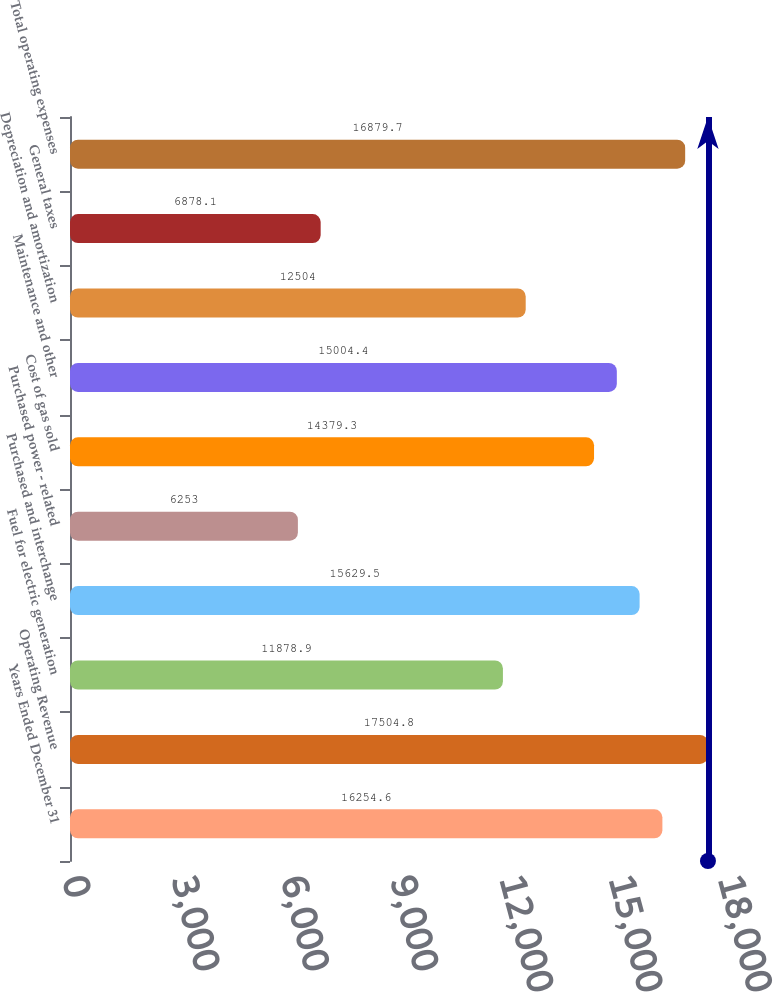Convert chart. <chart><loc_0><loc_0><loc_500><loc_500><bar_chart><fcel>Years Ended December 31<fcel>Operating Revenue<fcel>Fuel for electric generation<fcel>Purchased and interchange<fcel>Purchased power - related<fcel>Cost of gas sold<fcel>Maintenance and other<fcel>Depreciation and amortization<fcel>General taxes<fcel>Total operating expenses<nl><fcel>16254.6<fcel>17504.8<fcel>11878.9<fcel>15629.5<fcel>6253<fcel>14379.3<fcel>15004.4<fcel>12504<fcel>6878.1<fcel>16879.7<nl></chart> 